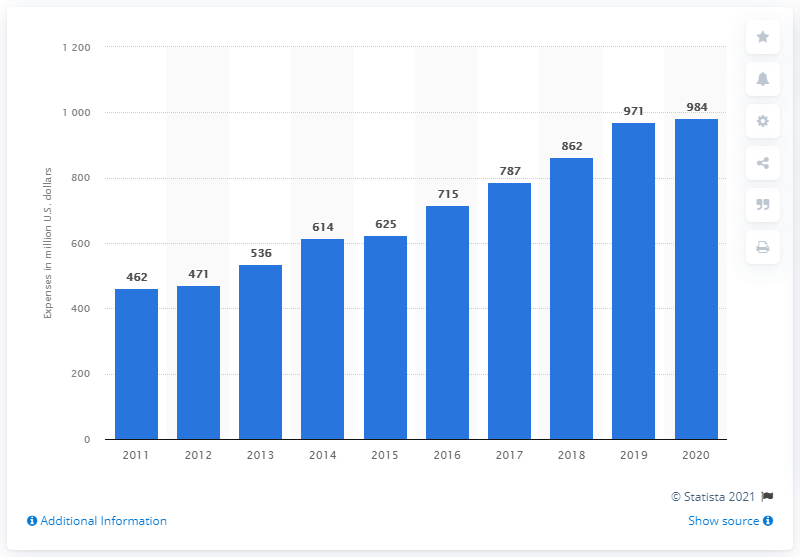Indicate a few pertinent items in this graphic. In 2020, Stryker spent a total of 984 million dollars on research, development, and engineering. 